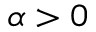<formula> <loc_0><loc_0><loc_500><loc_500>\alpha > 0</formula> 